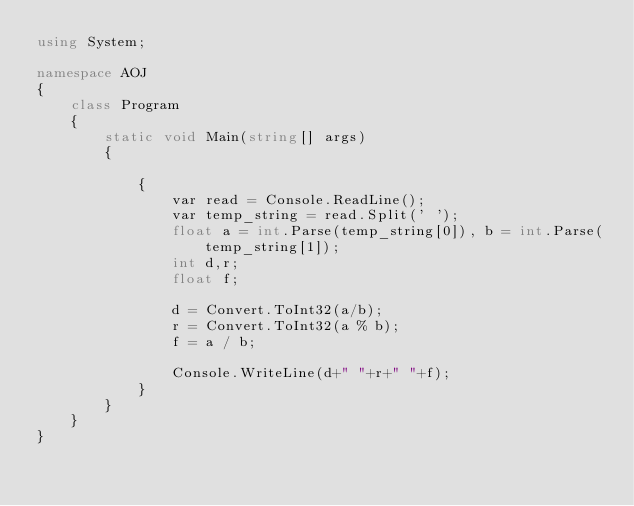Convert code to text. <code><loc_0><loc_0><loc_500><loc_500><_C#_>using System;

namespace AOJ
{
    class Program
    {
        static void Main(string[] args)
        {

            {
                var read = Console.ReadLine();
                var temp_string = read.Split(' ');
                float a = int.Parse(temp_string[0]), b = int.Parse(temp_string[1]);
                int d,r;
                float f;

                d = Convert.ToInt32(a/b);
                r = Convert.ToInt32(a % b);
                f = a / b;

                Console.WriteLine(d+" "+r+" "+f);
            }
        }
    }
}</code> 